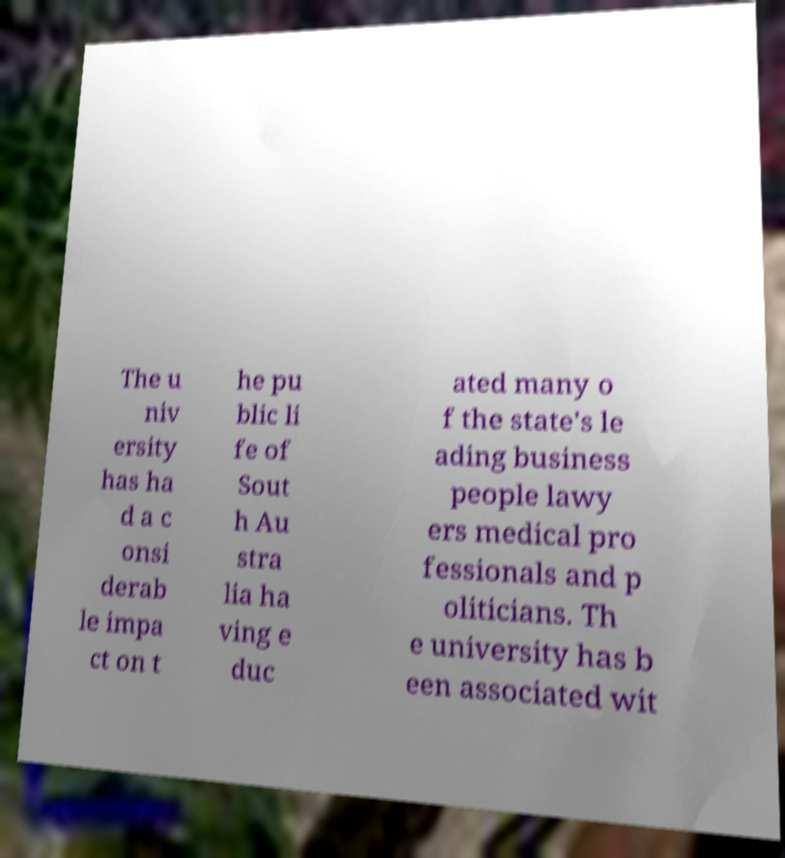What messages or text are displayed in this image? I need them in a readable, typed format. The u niv ersity has ha d a c onsi derab le impa ct on t he pu blic li fe of Sout h Au stra lia ha ving e duc ated many o f the state's le ading business people lawy ers medical pro fessionals and p oliticians. Th e university has b een associated wit 